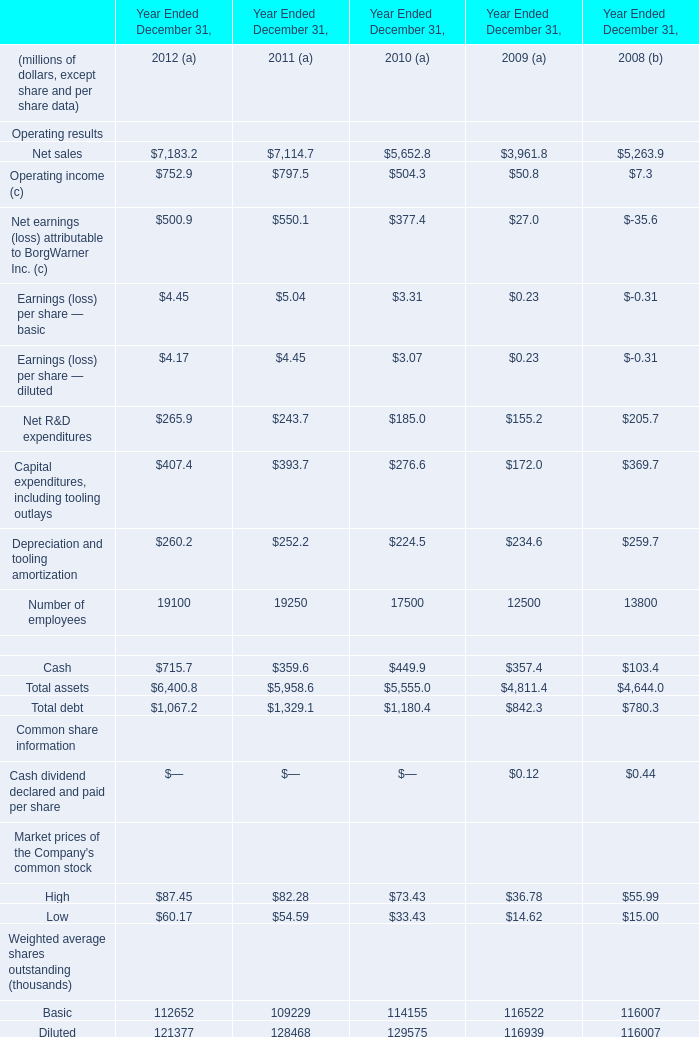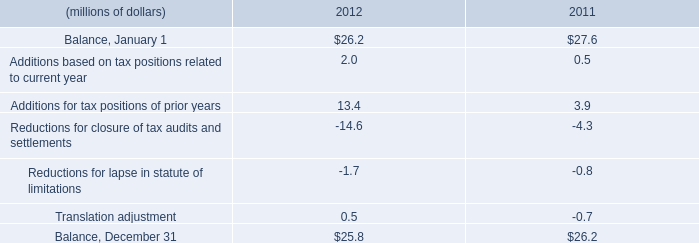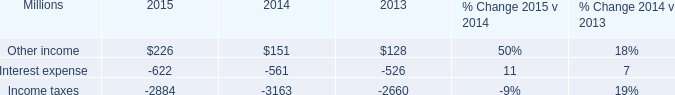What is the growing rate of Cash in the year with the most Net R&D expenditures? 
Computations: ((715.7 - 359.6) / 359.6)
Answer: 0.99027. 